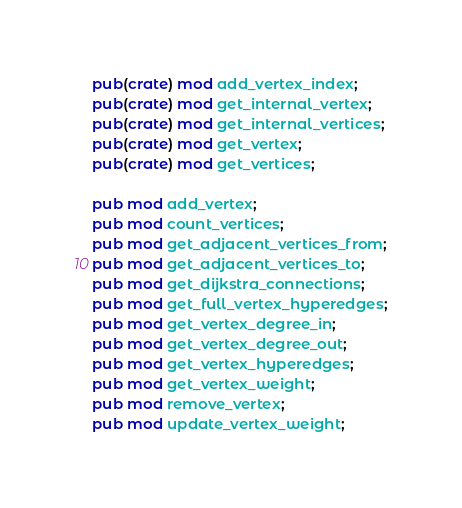Convert code to text. <code><loc_0><loc_0><loc_500><loc_500><_Rust_>pub(crate) mod add_vertex_index;
pub(crate) mod get_internal_vertex;
pub(crate) mod get_internal_vertices;
pub(crate) mod get_vertex;
pub(crate) mod get_vertices;

pub mod add_vertex;
pub mod count_vertices;
pub mod get_adjacent_vertices_from;
pub mod get_adjacent_vertices_to;
pub mod get_dijkstra_connections;
pub mod get_full_vertex_hyperedges;
pub mod get_vertex_degree_in;
pub mod get_vertex_degree_out;
pub mod get_vertex_hyperedges;
pub mod get_vertex_weight;
pub mod remove_vertex;
pub mod update_vertex_weight;
</code> 